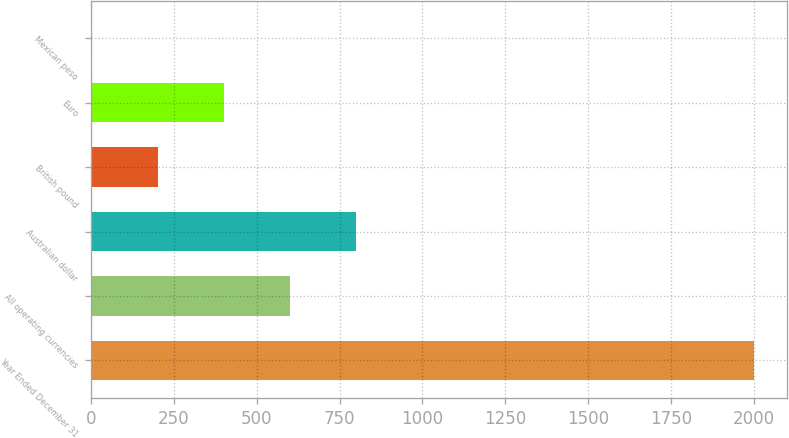Convert chart to OTSL. <chart><loc_0><loc_0><loc_500><loc_500><bar_chart><fcel>Year Ended December 31<fcel>All operating currencies<fcel>Australian dollar<fcel>British pound<fcel>Euro<fcel>Mexican peso<nl><fcel>2001<fcel>601<fcel>801<fcel>201<fcel>401<fcel>1<nl></chart> 